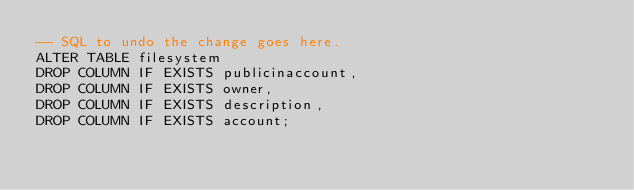<code> <loc_0><loc_0><loc_500><loc_500><_SQL_>-- SQL to undo the change goes here.
ALTER TABLE filesystem
DROP COLUMN IF EXISTS publicinaccount,
DROP COLUMN IF EXISTS owner,
DROP COLUMN IF EXISTS description,
DROP COLUMN IF EXISTS account;
</code> 